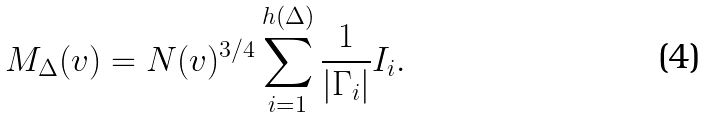<formula> <loc_0><loc_0><loc_500><loc_500>M _ { \Delta } ( v ) = N ( v ) ^ { 3 / 4 } \sum _ { i = 1 } ^ { h ( \Delta ) } \frac { 1 } { | \Gamma _ { i } | } I _ { i } .</formula> 